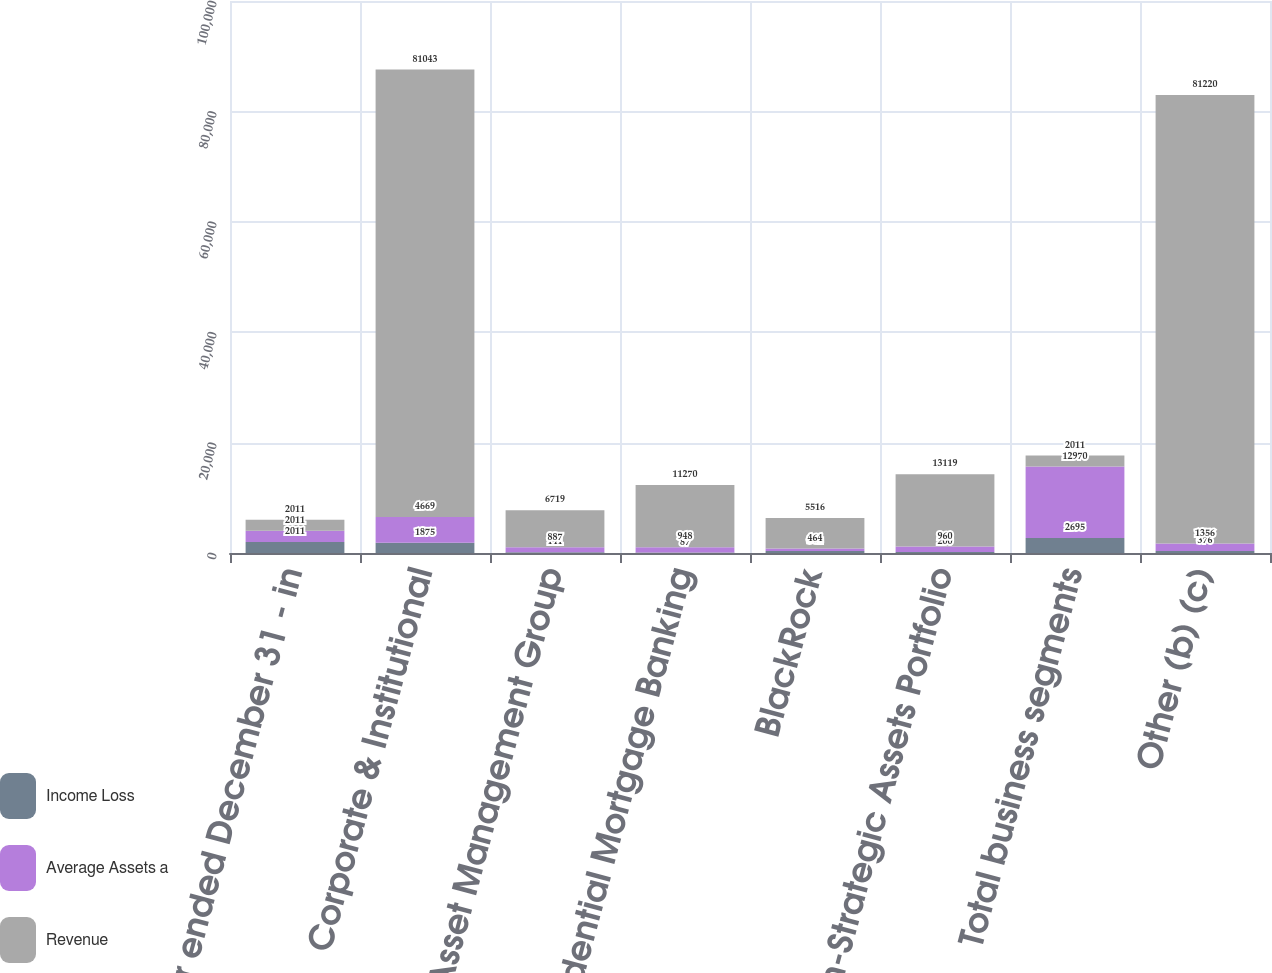Convert chart. <chart><loc_0><loc_0><loc_500><loc_500><stacked_bar_chart><ecel><fcel>Year ended December 31 - in<fcel>Corporate & Institutional<fcel>Asset Management Group<fcel>Residential Mortgage Banking<fcel>BlackRock<fcel>Non-Strategic Assets Portfolio<fcel>Total business segments<fcel>Other (b) (c)<nl><fcel>Income Loss<fcel>2011<fcel>1875<fcel>141<fcel>87<fcel>361<fcel>200<fcel>2695<fcel>376<nl><fcel>Average Assets a<fcel>2011<fcel>4669<fcel>887<fcel>948<fcel>464<fcel>960<fcel>12970<fcel>1356<nl><fcel>Revenue<fcel>2011<fcel>81043<fcel>6719<fcel>11270<fcel>5516<fcel>13119<fcel>2011<fcel>81220<nl></chart> 